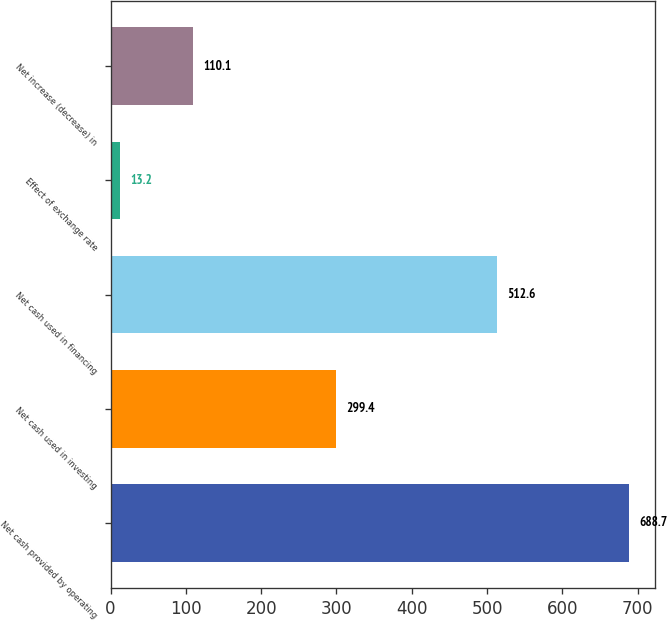<chart> <loc_0><loc_0><loc_500><loc_500><bar_chart><fcel>Net cash provided by operating<fcel>Net cash used in investing<fcel>Net cash used in financing<fcel>Effect of exchange rate<fcel>Net increase (decrease) in<nl><fcel>688.7<fcel>299.4<fcel>512.6<fcel>13.2<fcel>110.1<nl></chart> 